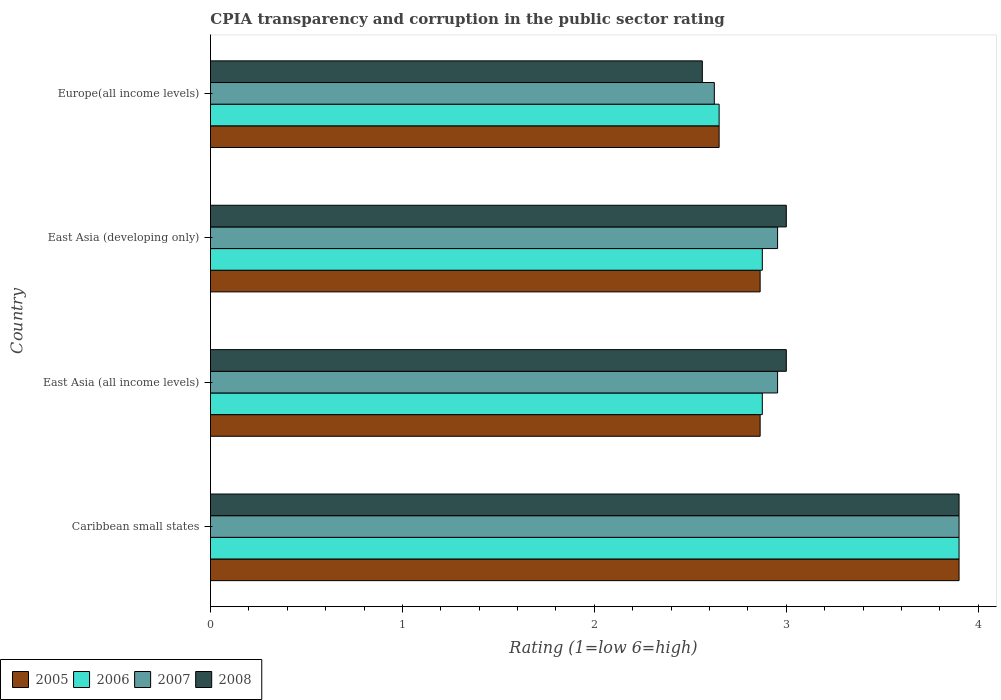Are the number of bars on each tick of the Y-axis equal?
Offer a very short reply. Yes. How many bars are there on the 2nd tick from the top?
Provide a short and direct response. 4. How many bars are there on the 4th tick from the bottom?
Offer a terse response. 4. What is the label of the 3rd group of bars from the top?
Your answer should be compact. East Asia (all income levels). What is the CPIA rating in 2006 in East Asia (developing only)?
Offer a terse response. 2.88. Across all countries, what is the minimum CPIA rating in 2005?
Provide a succinct answer. 2.65. In which country was the CPIA rating in 2007 maximum?
Provide a short and direct response. Caribbean small states. In which country was the CPIA rating in 2006 minimum?
Offer a very short reply. Europe(all income levels). What is the total CPIA rating in 2005 in the graph?
Give a very brief answer. 12.28. What is the difference between the CPIA rating in 2008 in Caribbean small states and that in East Asia (developing only)?
Your answer should be very brief. 0.9. What is the difference between the CPIA rating in 2007 in Caribbean small states and the CPIA rating in 2006 in Europe(all income levels)?
Offer a terse response. 1.25. What is the average CPIA rating in 2005 per country?
Provide a succinct answer. 3.07. What is the difference between the CPIA rating in 2007 and CPIA rating in 2006 in Caribbean small states?
Make the answer very short. 0. What is the ratio of the CPIA rating in 2007 in Caribbean small states to that in East Asia (all income levels)?
Ensure brevity in your answer.  1.32. Is the CPIA rating in 2005 in East Asia (developing only) less than that in Europe(all income levels)?
Offer a very short reply. No. What is the difference between the highest and the second highest CPIA rating in 2007?
Offer a very short reply. 0.95. What is the difference between the highest and the lowest CPIA rating in 2007?
Offer a very short reply. 1.27. Is it the case that in every country, the sum of the CPIA rating in 2007 and CPIA rating in 2005 is greater than the CPIA rating in 2008?
Keep it short and to the point. Yes. How many bars are there?
Your response must be concise. 16. How many countries are there in the graph?
Provide a short and direct response. 4. Does the graph contain any zero values?
Your response must be concise. No. Where does the legend appear in the graph?
Make the answer very short. Bottom left. How are the legend labels stacked?
Your response must be concise. Horizontal. What is the title of the graph?
Your answer should be very brief. CPIA transparency and corruption in the public sector rating. What is the label or title of the Y-axis?
Make the answer very short. Country. What is the Rating (1=low 6=high) in 2007 in Caribbean small states?
Give a very brief answer. 3.9. What is the Rating (1=low 6=high) of 2005 in East Asia (all income levels)?
Offer a terse response. 2.86. What is the Rating (1=low 6=high) of 2006 in East Asia (all income levels)?
Give a very brief answer. 2.88. What is the Rating (1=low 6=high) in 2007 in East Asia (all income levels)?
Give a very brief answer. 2.95. What is the Rating (1=low 6=high) of 2005 in East Asia (developing only)?
Provide a short and direct response. 2.86. What is the Rating (1=low 6=high) of 2006 in East Asia (developing only)?
Offer a terse response. 2.88. What is the Rating (1=low 6=high) in 2007 in East Asia (developing only)?
Offer a very short reply. 2.95. What is the Rating (1=low 6=high) in 2008 in East Asia (developing only)?
Offer a terse response. 3. What is the Rating (1=low 6=high) in 2005 in Europe(all income levels)?
Provide a short and direct response. 2.65. What is the Rating (1=low 6=high) of 2006 in Europe(all income levels)?
Provide a short and direct response. 2.65. What is the Rating (1=low 6=high) of 2007 in Europe(all income levels)?
Ensure brevity in your answer.  2.62. What is the Rating (1=low 6=high) of 2008 in Europe(all income levels)?
Make the answer very short. 2.56. Across all countries, what is the maximum Rating (1=low 6=high) of 2005?
Offer a terse response. 3.9. Across all countries, what is the minimum Rating (1=low 6=high) of 2005?
Make the answer very short. 2.65. Across all countries, what is the minimum Rating (1=low 6=high) of 2006?
Offer a terse response. 2.65. Across all countries, what is the minimum Rating (1=low 6=high) in 2007?
Make the answer very short. 2.62. Across all countries, what is the minimum Rating (1=low 6=high) in 2008?
Keep it short and to the point. 2.56. What is the total Rating (1=low 6=high) in 2005 in the graph?
Provide a succinct answer. 12.28. What is the total Rating (1=low 6=high) of 2006 in the graph?
Keep it short and to the point. 12.3. What is the total Rating (1=low 6=high) of 2007 in the graph?
Keep it short and to the point. 12.43. What is the total Rating (1=low 6=high) in 2008 in the graph?
Offer a very short reply. 12.46. What is the difference between the Rating (1=low 6=high) of 2005 in Caribbean small states and that in East Asia (all income levels)?
Your response must be concise. 1.04. What is the difference between the Rating (1=low 6=high) in 2007 in Caribbean small states and that in East Asia (all income levels)?
Your response must be concise. 0.95. What is the difference between the Rating (1=low 6=high) of 2005 in Caribbean small states and that in East Asia (developing only)?
Provide a short and direct response. 1.04. What is the difference between the Rating (1=low 6=high) of 2007 in Caribbean small states and that in East Asia (developing only)?
Your response must be concise. 0.95. What is the difference between the Rating (1=low 6=high) of 2007 in Caribbean small states and that in Europe(all income levels)?
Your answer should be compact. 1.27. What is the difference between the Rating (1=low 6=high) of 2008 in Caribbean small states and that in Europe(all income levels)?
Make the answer very short. 1.34. What is the difference between the Rating (1=low 6=high) in 2006 in East Asia (all income levels) and that in East Asia (developing only)?
Your answer should be very brief. 0. What is the difference between the Rating (1=low 6=high) of 2007 in East Asia (all income levels) and that in East Asia (developing only)?
Offer a very short reply. 0. What is the difference between the Rating (1=low 6=high) in 2008 in East Asia (all income levels) and that in East Asia (developing only)?
Offer a terse response. 0. What is the difference between the Rating (1=low 6=high) in 2005 in East Asia (all income levels) and that in Europe(all income levels)?
Keep it short and to the point. 0.21. What is the difference between the Rating (1=low 6=high) in 2006 in East Asia (all income levels) and that in Europe(all income levels)?
Keep it short and to the point. 0.23. What is the difference between the Rating (1=low 6=high) in 2007 in East Asia (all income levels) and that in Europe(all income levels)?
Your answer should be very brief. 0.33. What is the difference between the Rating (1=low 6=high) in 2008 in East Asia (all income levels) and that in Europe(all income levels)?
Your answer should be compact. 0.44. What is the difference between the Rating (1=low 6=high) in 2005 in East Asia (developing only) and that in Europe(all income levels)?
Offer a very short reply. 0.21. What is the difference between the Rating (1=low 6=high) in 2006 in East Asia (developing only) and that in Europe(all income levels)?
Offer a very short reply. 0.23. What is the difference between the Rating (1=low 6=high) in 2007 in East Asia (developing only) and that in Europe(all income levels)?
Your response must be concise. 0.33. What is the difference between the Rating (1=low 6=high) in 2008 in East Asia (developing only) and that in Europe(all income levels)?
Your answer should be compact. 0.44. What is the difference between the Rating (1=low 6=high) of 2005 in Caribbean small states and the Rating (1=low 6=high) of 2007 in East Asia (all income levels)?
Provide a succinct answer. 0.95. What is the difference between the Rating (1=low 6=high) of 2006 in Caribbean small states and the Rating (1=low 6=high) of 2007 in East Asia (all income levels)?
Keep it short and to the point. 0.95. What is the difference between the Rating (1=low 6=high) of 2006 in Caribbean small states and the Rating (1=low 6=high) of 2008 in East Asia (all income levels)?
Provide a succinct answer. 0.9. What is the difference between the Rating (1=low 6=high) in 2007 in Caribbean small states and the Rating (1=low 6=high) in 2008 in East Asia (all income levels)?
Your response must be concise. 0.9. What is the difference between the Rating (1=low 6=high) of 2005 in Caribbean small states and the Rating (1=low 6=high) of 2006 in East Asia (developing only)?
Offer a terse response. 1.02. What is the difference between the Rating (1=low 6=high) of 2005 in Caribbean small states and the Rating (1=low 6=high) of 2007 in East Asia (developing only)?
Your answer should be compact. 0.95. What is the difference between the Rating (1=low 6=high) in 2005 in Caribbean small states and the Rating (1=low 6=high) in 2008 in East Asia (developing only)?
Give a very brief answer. 0.9. What is the difference between the Rating (1=low 6=high) of 2006 in Caribbean small states and the Rating (1=low 6=high) of 2007 in East Asia (developing only)?
Keep it short and to the point. 0.95. What is the difference between the Rating (1=low 6=high) of 2006 in Caribbean small states and the Rating (1=low 6=high) of 2008 in East Asia (developing only)?
Offer a terse response. 0.9. What is the difference between the Rating (1=low 6=high) of 2007 in Caribbean small states and the Rating (1=low 6=high) of 2008 in East Asia (developing only)?
Provide a succinct answer. 0.9. What is the difference between the Rating (1=low 6=high) in 2005 in Caribbean small states and the Rating (1=low 6=high) in 2007 in Europe(all income levels)?
Your answer should be very brief. 1.27. What is the difference between the Rating (1=low 6=high) of 2005 in Caribbean small states and the Rating (1=low 6=high) of 2008 in Europe(all income levels)?
Your answer should be compact. 1.34. What is the difference between the Rating (1=low 6=high) of 2006 in Caribbean small states and the Rating (1=low 6=high) of 2007 in Europe(all income levels)?
Offer a very short reply. 1.27. What is the difference between the Rating (1=low 6=high) in 2006 in Caribbean small states and the Rating (1=low 6=high) in 2008 in Europe(all income levels)?
Offer a very short reply. 1.34. What is the difference between the Rating (1=low 6=high) in 2007 in Caribbean small states and the Rating (1=low 6=high) in 2008 in Europe(all income levels)?
Provide a succinct answer. 1.34. What is the difference between the Rating (1=low 6=high) in 2005 in East Asia (all income levels) and the Rating (1=low 6=high) in 2006 in East Asia (developing only)?
Provide a succinct answer. -0.01. What is the difference between the Rating (1=low 6=high) of 2005 in East Asia (all income levels) and the Rating (1=low 6=high) of 2007 in East Asia (developing only)?
Provide a short and direct response. -0.09. What is the difference between the Rating (1=low 6=high) in 2005 in East Asia (all income levels) and the Rating (1=low 6=high) in 2008 in East Asia (developing only)?
Make the answer very short. -0.14. What is the difference between the Rating (1=low 6=high) of 2006 in East Asia (all income levels) and the Rating (1=low 6=high) of 2007 in East Asia (developing only)?
Offer a terse response. -0.08. What is the difference between the Rating (1=low 6=high) in 2006 in East Asia (all income levels) and the Rating (1=low 6=high) in 2008 in East Asia (developing only)?
Offer a terse response. -0.12. What is the difference between the Rating (1=low 6=high) in 2007 in East Asia (all income levels) and the Rating (1=low 6=high) in 2008 in East Asia (developing only)?
Provide a short and direct response. -0.05. What is the difference between the Rating (1=low 6=high) in 2005 in East Asia (all income levels) and the Rating (1=low 6=high) in 2006 in Europe(all income levels)?
Your response must be concise. 0.21. What is the difference between the Rating (1=low 6=high) in 2005 in East Asia (all income levels) and the Rating (1=low 6=high) in 2007 in Europe(all income levels)?
Keep it short and to the point. 0.24. What is the difference between the Rating (1=low 6=high) of 2005 in East Asia (all income levels) and the Rating (1=low 6=high) of 2008 in Europe(all income levels)?
Your response must be concise. 0.3. What is the difference between the Rating (1=low 6=high) in 2006 in East Asia (all income levels) and the Rating (1=low 6=high) in 2008 in Europe(all income levels)?
Give a very brief answer. 0.31. What is the difference between the Rating (1=low 6=high) in 2007 in East Asia (all income levels) and the Rating (1=low 6=high) in 2008 in Europe(all income levels)?
Provide a succinct answer. 0.39. What is the difference between the Rating (1=low 6=high) of 2005 in East Asia (developing only) and the Rating (1=low 6=high) of 2006 in Europe(all income levels)?
Provide a succinct answer. 0.21. What is the difference between the Rating (1=low 6=high) of 2005 in East Asia (developing only) and the Rating (1=low 6=high) of 2007 in Europe(all income levels)?
Ensure brevity in your answer.  0.24. What is the difference between the Rating (1=low 6=high) in 2005 in East Asia (developing only) and the Rating (1=low 6=high) in 2008 in Europe(all income levels)?
Offer a terse response. 0.3. What is the difference between the Rating (1=low 6=high) in 2006 in East Asia (developing only) and the Rating (1=low 6=high) in 2008 in Europe(all income levels)?
Offer a very short reply. 0.31. What is the difference between the Rating (1=low 6=high) of 2007 in East Asia (developing only) and the Rating (1=low 6=high) of 2008 in Europe(all income levels)?
Provide a short and direct response. 0.39. What is the average Rating (1=low 6=high) of 2005 per country?
Offer a very short reply. 3.07. What is the average Rating (1=low 6=high) of 2006 per country?
Your answer should be very brief. 3.08. What is the average Rating (1=low 6=high) of 2007 per country?
Provide a succinct answer. 3.11. What is the average Rating (1=low 6=high) in 2008 per country?
Ensure brevity in your answer.  3.12. What is the difference between the Rating (1=low 6=high) in 2006 and Rating (1=low 6=high) in 2008 in Caribbean small states?
Your answer should be very brief. 0. What is the difference between the Rating (1=low 6=high) in 2005 and Rating (1=low 6=high) in 2006 in East Asia (all income levels)?
Offer a terse response. -0.01. What is the difference between the Rating (1=low 6=high) in 2005 and Rating (1=low 6=high) in 2007 in East Asia (all income levels)?
Keep it short and to the point. -0.09. What is the difference between the Rating (1=low 6=high) of 2005 and Rating (1=low 6=high) of 2008 in East Asia (all income levels)?
Your answer should be compact. -0.14. What is the difference between the Rating (1=low 6=high) of 2006 and Rating (1=low 6=high) of 2007 in East Asia (all income levels)?
Give a very brief answer. -0.08. What is the difference between the Rating (1=low 6=high) of 2006 and Rating (1=low 6=high) of 2008 in East Asia (all income levels)?
Keep it short and to the point. -0.12. What is the difference between the Rating (1=low 6=high) of 2007 and Rating (1=low 6=high) of 2008 in East Asia (all income levels)?
Offer a terse response. -0.05. What is the difference between the Rating (1=low 6=high) in 2005 and Rating (1=low 6=high) in 2006 in East Asia (developing only)?
Offer a very short reply. -0.01. What is the difference between the Rating (1=low 6=high) of 2005 and Rating (1=low 6=high) of 2007 in East Asia (developing only)?
Give a very brief answer. -0.09. What is the difference between the Rating (1=low 6=high) in 2005 and Rating (1=low 6=high) in 2008 in East Asia (developing only)?
Offer a very short reply. -0.14. What is the difference between the Rating (1=low 6=high) in 2006 and Rating (1=low 6=high) in 2007 in East Asia (developing only)?
Your answer should be very brief. -0.08. What is the difference between the Rating (1=low 6=high) in 2006 and Rating (1=low 6=high) in 2008 in East Asia (developing only)?
Ensure brevity in your answer.  -0.12. What is the difference between the Rating (1=low 6=high) in 2007 and Rating (1=low 6=high) in 2008 in East Asia (developing only)?
Offer a terse response. -0.05. What is the difference between the Rating (1=low 6=high) in 2005 and Rating (1=low 6=high) in 2006 in Europe(all income levels)?
Provide a short and direct response. 0. What is the difference between the Rating (1=low 6=high) of 2005 and Rating (1=low 6=high) of 2007 in Europe(all income levels)?
Offer a very short reply. 0.03. What is the difference between the Rating (1=low 6=high) in 2005 and Rating (1=low 6=high) in 2008 in Europe(all income levels)?
Give a very brief answer. 0.09. What is the difference between the Rating (1=low 6=high) of 2006 and Rating (1=low 6=high) of 2007 in Europe(all income levels)?
Ensure brevity in your answer.  0.03. What is the difference between the Rating (1=low 6=high) of 2006 and Rating (1=low 6=high) of 2008 in Europe(all income levels)?
Provide a short and direct response. 0.09. What is the difference between the Rating (1=low 6=high) of 2007 and Rating (1=low 6=high) of 2008 in Europe(all income levels)?
Ensure brevity in your answer.  0.06. What is the ratio of the Rating (1=low 6=high) of 2005 in Caribbean small states to that in East Asia (all income levels)?
Offer a terse response. 1.36. What is the ratio of the Rating (1=low 6=high) in 2006 in Caribbean small states to that in East Asia (all income levels)?
Provide a short and direct response. 1.36. What is the ratio of the Rating (1=low 6=high) of 2007 in Caribbean small states to that in East Asia (all income levels)?
Ensure brevity in your answer.  1.32. What is the ratio of the Rating (1=low 6=high) in 2005 in Caribbean small states to that in East Asia (developing only)?
Provide a short and direct response. 1.36. What is the ratio of the Rating (1=low 6=high) in 2006 in Caribbean small states to that in East Asia (developing only)?
Give a very brief answer. 1.36. What is the ratio of the Rating (1=low 6=high) of 2007 in Caribbean small states to that in East Asia (developing only)?
Your response must be concise. 1.32. What is the ratio of the Rating (1=low 6=high) in 2005 in Caribbean small states to that in Europe(all income levels)?
Make the answer very short. 1.47. What is the ratio of the Rating (1=low 6=high) of 2006 in Caribbean small states to that in Europe(all income levels)?
Your response must be concise. 1.47. What is the ratio of the Rating (1=low 6=high) of 2007 in Caribbean small states to that in Europe(all income levels)?
Offer a terse response. 1.49. What is the ratio of the Rating (1=low 6=high) in 2008 in Caribbean small states to that in Europe(all income levels)?
Make the answer very short. 1.52. What is the ratio of the Rating (1=low 6=high) of 2005 in East Asia (all income levels) to that in East Asia (developing only)?
Give a very brief answer. 1. What is the ratio of the Rating (1=low 6=high) in 2006 in East Asia (all income levels) to that in East Asia (developing only)?
Offer a very short reply. 1. What is the ratio of the Rating (1=low 6=high) of 2005 in East Asia (all income levels) to that in Europe(all income levels)?
Make the answer very short. 1.08. What is the ratio of the Rating (1=low 6=high) in 2006 in East Asia (all income levels) to that in Europe(all income levels)?
Ensure brevity in your answer.  1.08. What is the ratio of the Rating (1=low 6=high) in 2007 in East Asia (all income levels) to that in Europe(all income levels)?
Ensure brevity in your answer.  1.13. What is the ratio of the Rating (1=low 6=high) of 2008 in East Asia (all income levels) to that in Europe(all income levels)?
Provide a short and direct response. 1.17. What is the ratio of the Rating (1=low 6=high) of 2005 in East Asia (developing only) to that in Europe(all income levels)?
Offer a terse response. 1.08. What is the ratio of the Rating (1=low 6=high) in 2006 in East Asia (developing only) to that in Europe(all income levels)?
Your answer should be very brief. 1.08. What is the ratio of the Rating (1=low 6=high) in 2007 in East Asia (developing only) to that in Europe(all income levels)?
Provide a succinct answer. 1.13. What is the ratio of the Rating (1=low 6=high) of 2008 in East Asia (developing only) to that in Europe(all income levels)?
Ensure brevity in your answer.  1.17. What is the difference between the highest and the second highest Rating (1=low 6=high) of 2005?
Make the answer very short. 1.04. What is the difference between the highest and the second highest Rating (1=low 6=high) in 2006?
Make the answer very short. 1.02. What is the difference between the highest and the second highest Rating (1=low 6=high) of 2007?
Your response must be concise. 0.95. What is the difference between the highest and the second highest Rating (1=low 6=high) in 2008?
Give a very brief answer. 0.9. What is the difference between the highest and the lowest Rating (1=low 6=high) in 2006?
Offer a terse response. 1.25. What is the difference between the highest and the lowest Rating (1=low 6=high) of 2007?
Give a very brief answer. 1.27. What is the difference between the highest and the lowest Rating (1=low 6=high) of 2008?
Offer a terse response. 1.34. 